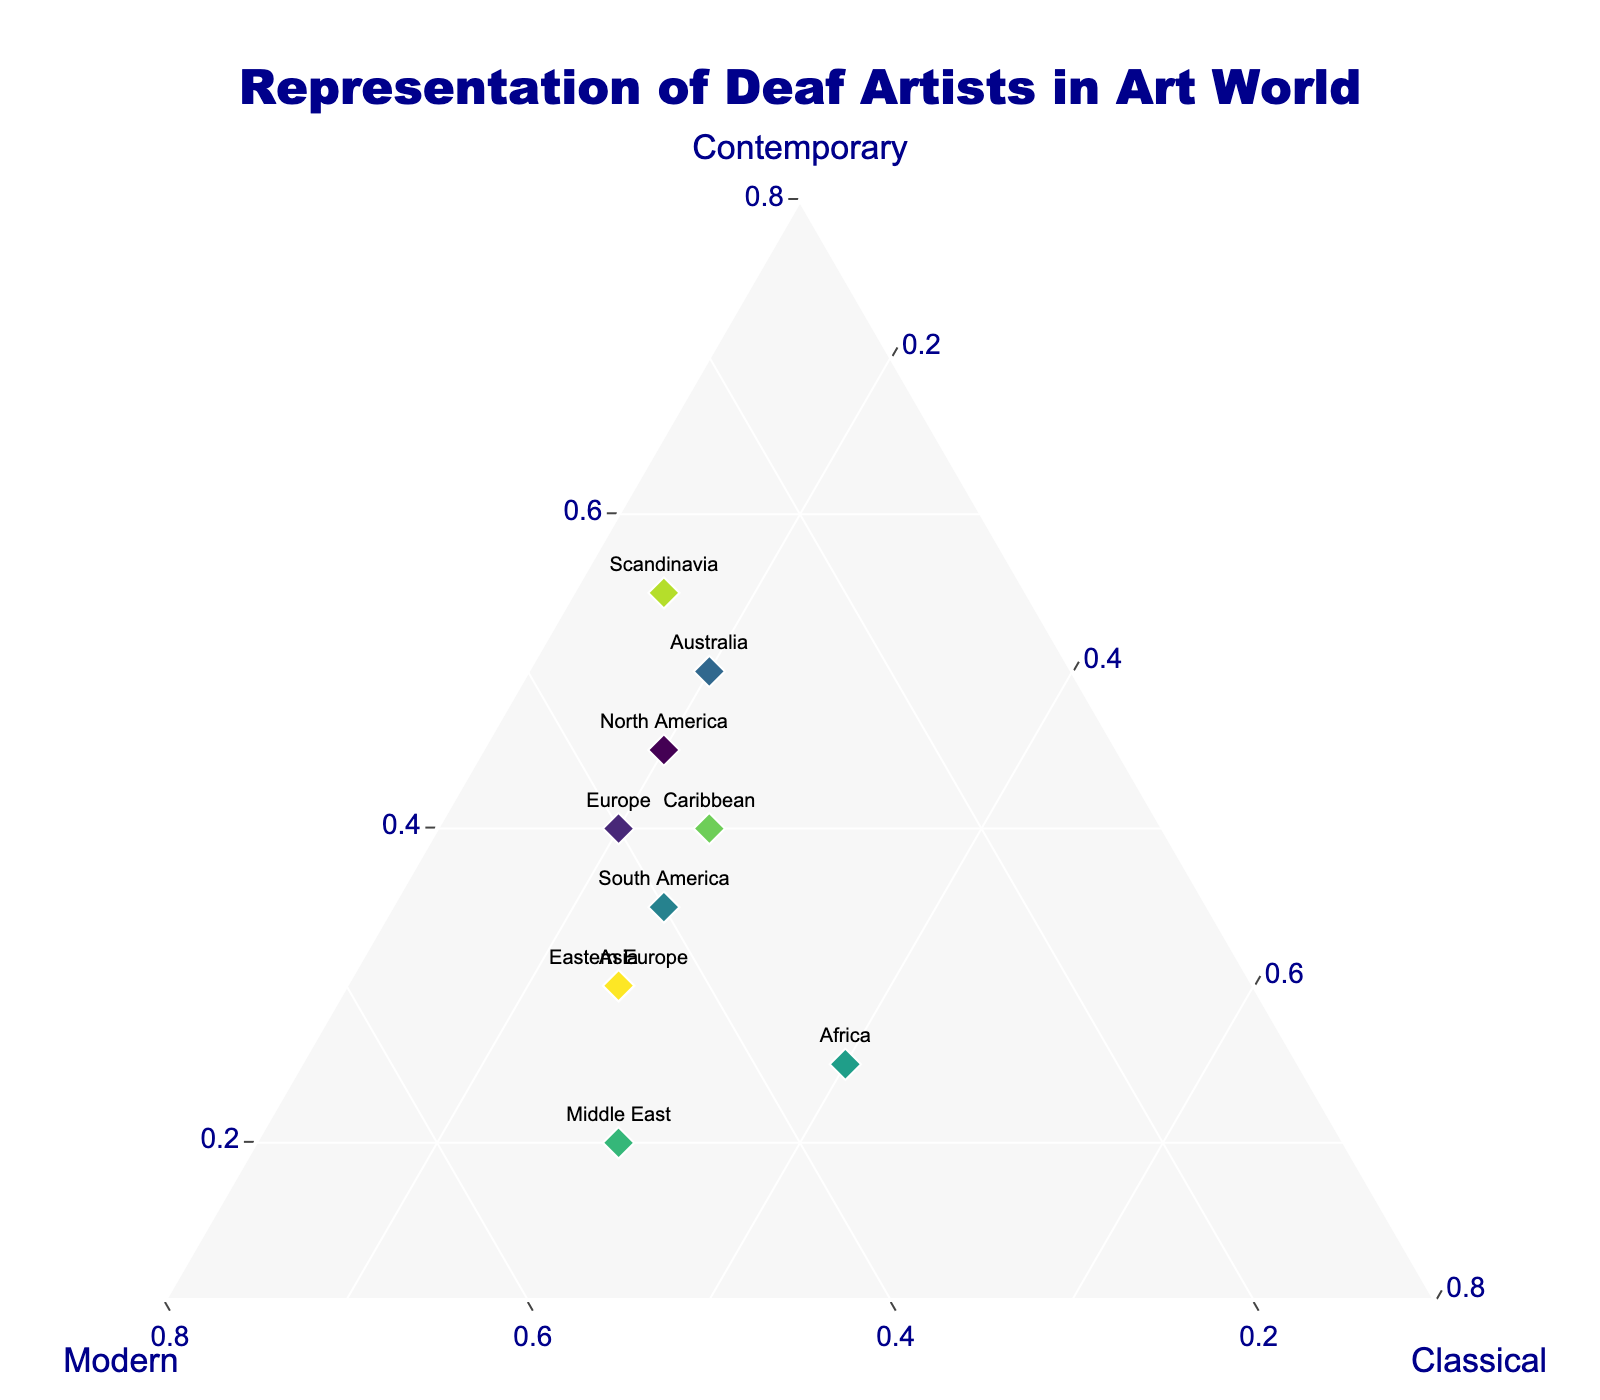What is the title of the figure? The title is usually placed at the top of the figure and is given to provide a high-level description of what the plot is about. Here it reads, "Representation of Deaf Artists in Art World".
Answer: Representation of Deaf Artists in Art World Which region has the highest representation of Contemporary style? To determine this, look for the data point that is farthest towards the vertex labeled 'Contemporary'. This corresponds to Scandinavia with a value of 0.55.
Answer: Scandinavia Which regions have an equal representation in Modern and Classical styles? Look for data points exactly between the 'Modern' and 'Classical' vertices. The region that fulfills this condition is Europe with both styles represented by 0.40 each.
Answer: Europe What is the representation of Classical style in Africa? Identify the data point labeled 'Africa' and observe its position relative to the 'Classical' axis. The value is 0.40.
Answer: 0.40 What is the average representation of Modern style across all regions? To find the average, sum all the values for Modern style and divide by the number of regions. The calculation is (0.35 + 0.40 + 0.45 + 0.30 + 0.40 + 0.35 + 0.50 + 0.35 + 0.30 + 0.45) / 10 = 3.85 / 10 = 0.385.
Answer: 0.385 Which region shows the least representation of Classical style? Identify the data point closest to the base of the 'Classical' vertex. Scandinavia is the closest with a value of 0.15.
Answer: Scandinavia How does the representation of Modern style in Asia compare to North America? Compare the respective values for Modern style directly. Asia has 0.45 while North America has 0.35, so Asia has a higher representation.
Answer: Asia has a higher representation Which region has an equal representation among all three styles? Look for a data point equidistant from all three vertices. None of the regions in this plot has equal representation in Contemporary, Modern, and Classical styles.
Answer: None What is the range of Contemporary representation values provided? Identify the highest and lowest values from the 'Contemporary' column. The highest is 0.55 (Scandinavia) and the lowest is 0.20 (Middle East). The range is 0.55 - 0.20 = 0.35.
Answer: 0.35 